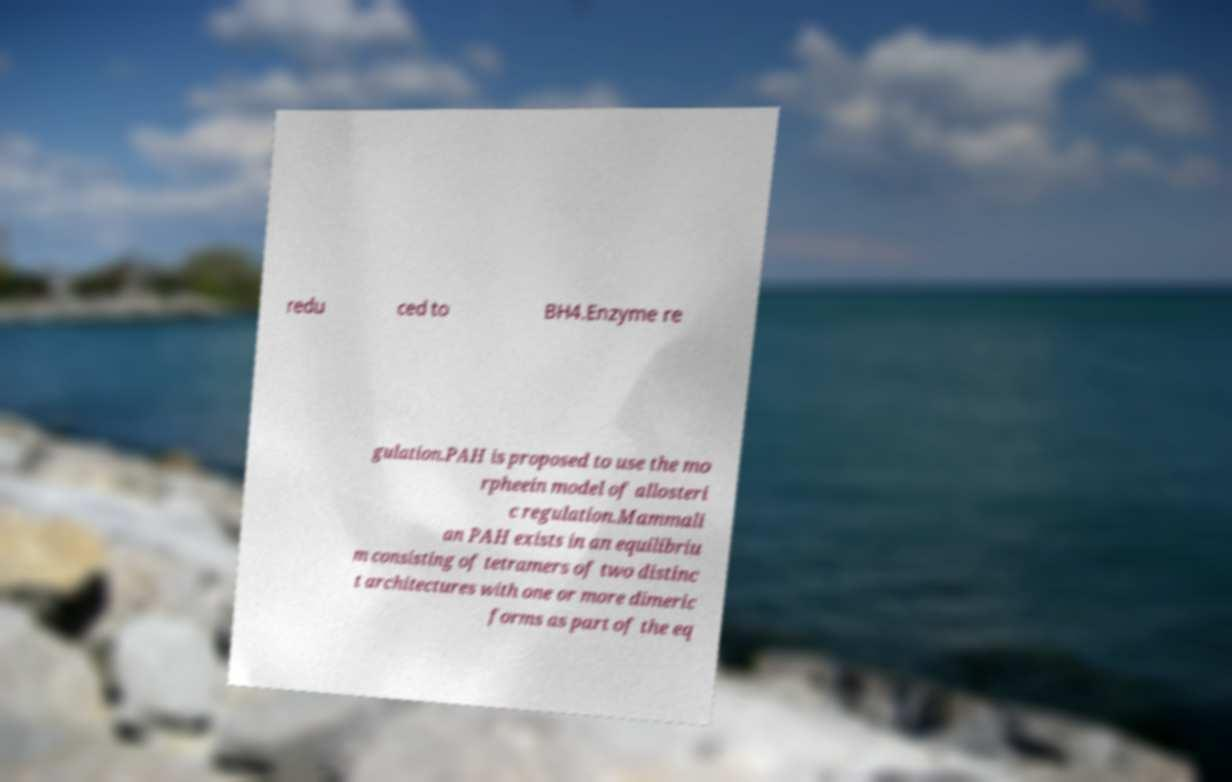Could you extract and type out the text from this image? redu ced to BH4.Enzyme re gulation.PAH is proposed to use the mo rpheein model of allosteri c regulation.Mammali an PAH exists in an equilibriu m consisting of tetramers of two distinc t architectures with one or more dimeric forms as part of the eq 